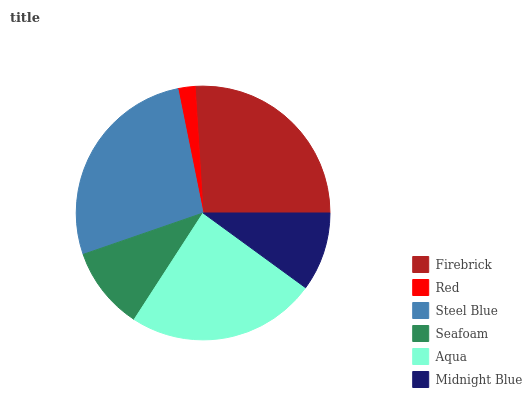Is Red the minimum?
Answer yes or no. Yes. Is Steel Blue the maximum?
Answer yes or no. Yes. Is Steel Blue the minimum?
Answer yes or no. No. Is Red the maximum?
Answer yes or no. No. Is Steel Blue greater than Red?
Answer yes or no. Yes. Is Red less than Steel Blue?
Answer yes or no. Yes. Is Red greater than Steel Blue?
Answer yes or no. No. Is Steel Blue less than Red?
Answer yes or no. No. Is Aqua the high median?
Answer yes or no. Yes. Is Seafoam the low median?
Answer yes or no. Yes. Is Midnight Blue the high median?
Answer yes or no. No. Is Midnight Blue the low median?
Answer yes or no. No. 